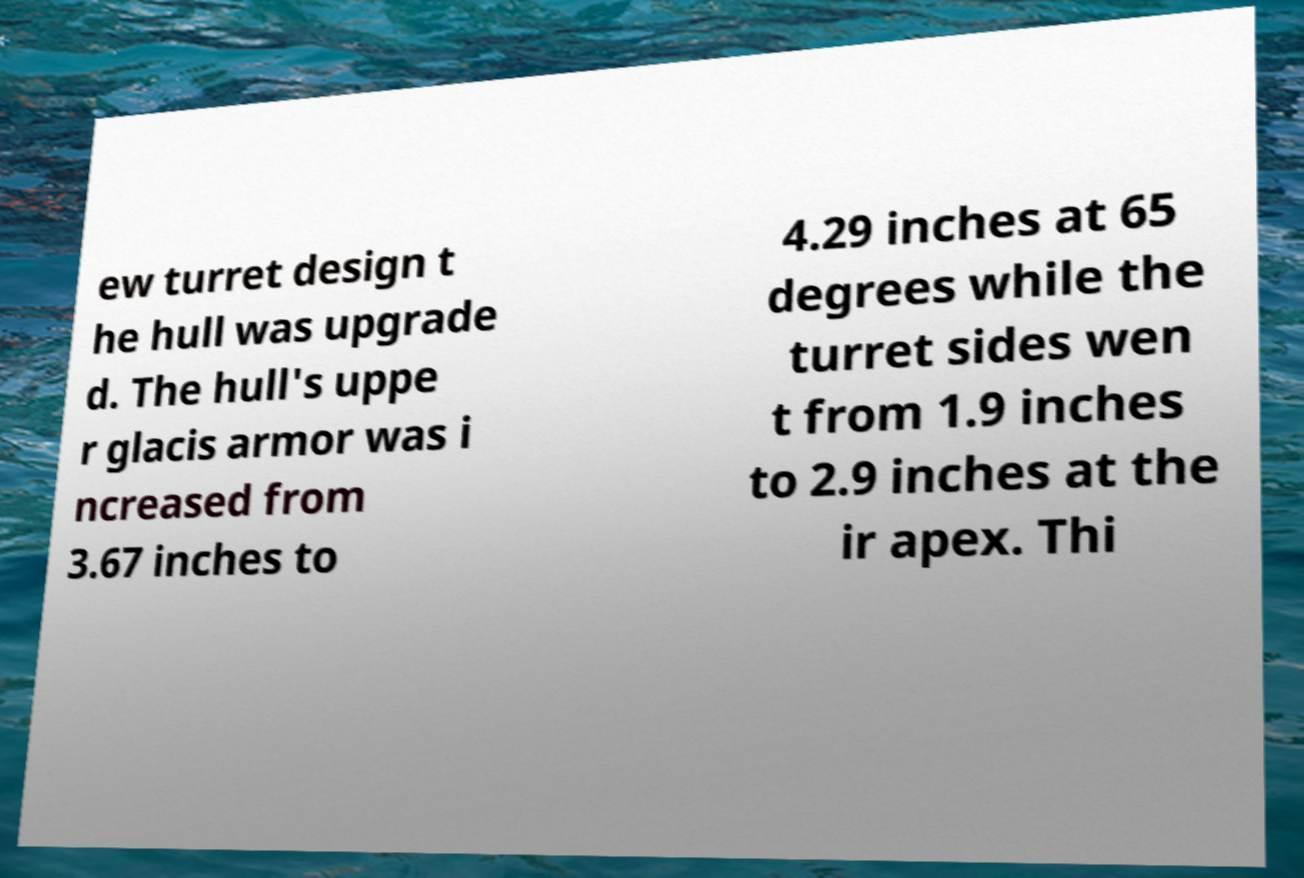I need the written content from this picture converted into text. Can you do that? ew turret design t he hull was upgrade d. The hull's uppe r glacis armor was i ncreased from 3.67 inches to 4.29 inches at 65 degrees while the turret sides wen t from 1.9 inches to 2.9 inches at the ir apex. Thi 